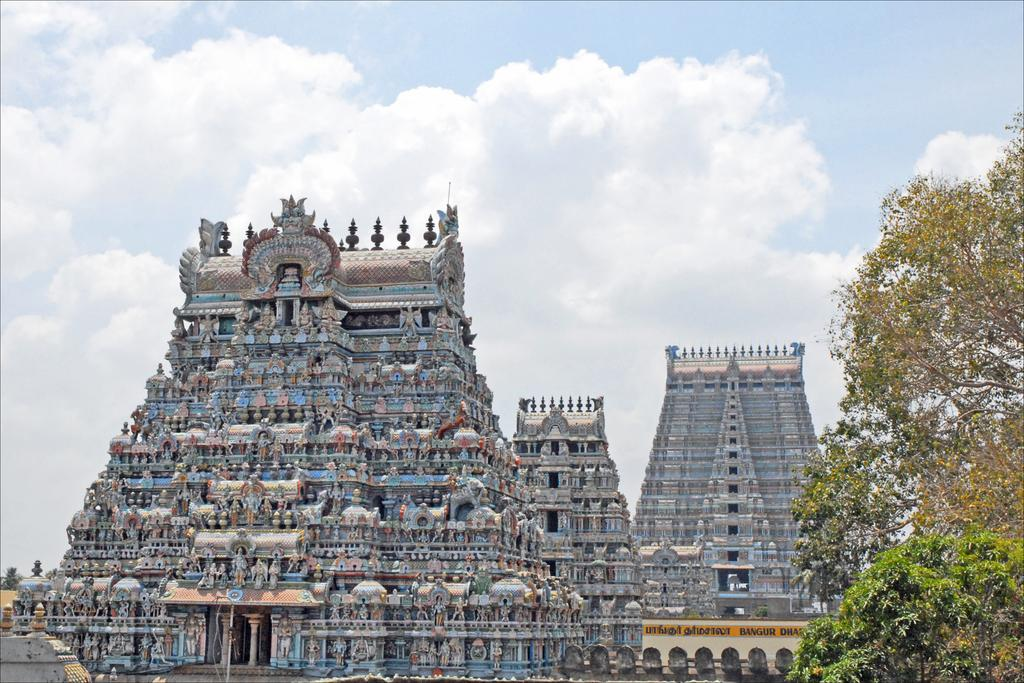What type of structure is in the image? There is a temple in the image. What can be seen on the sides of the image? There are trees on both the right and left sides of the image. What is visible in the background of the image? The sky is visible in the background of the image. What type of stone is being used to lead the temple in the image? There is no indication in the image that the temple is being led by any type of stone. 